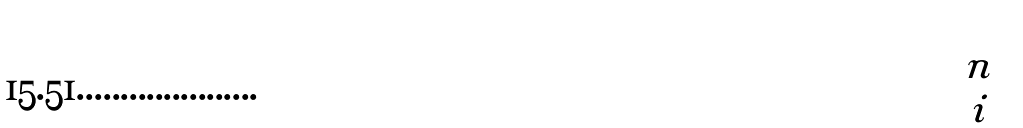<formula> <loc_0><loc_0><loc_500><loc_500>\begin{pmatrix} n \\ i \end{pmatrix}</formula> 